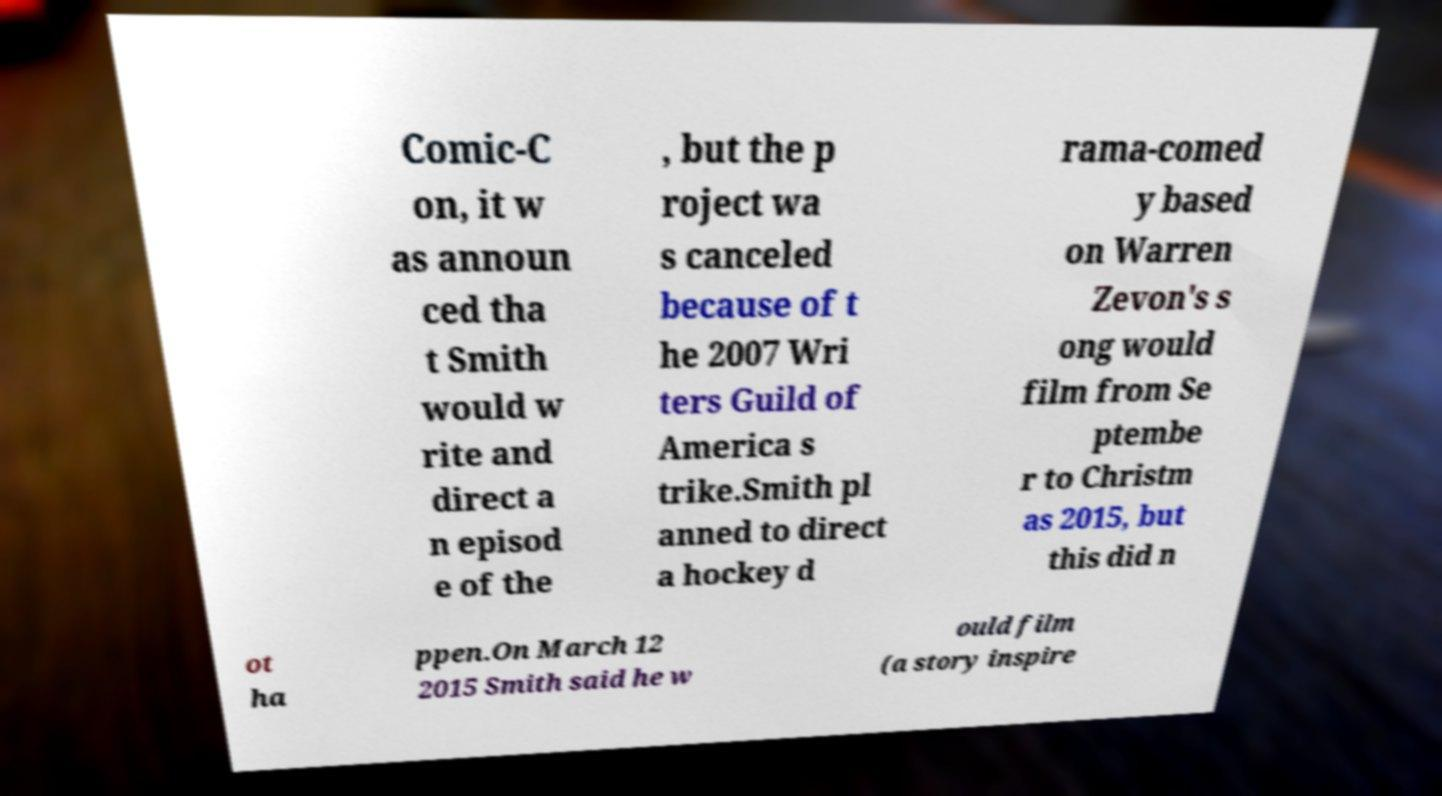Please identify and transcribe the text found in this image. Comic-C on, it w as announ ced tha t Smith would w rite and direct a n episod e of the , but the p roject wa s canceled because of t he 2007 Wri ters Guild of America s trike.Smith pl anned to direct a hockey d rama-comed y based on Warren Zevon's s ong would film from Se ptembe r to Christm as 2015, but this did n ot ha ppen.On March 12 2015 Smith said he w ould film (a story inspire 